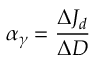<formula> <loc_0><loc_0><loc_500><loc_500>\alpha _ { \gamma } = \frac { \Delta J _ { d } } { \Delta D }</formula> 